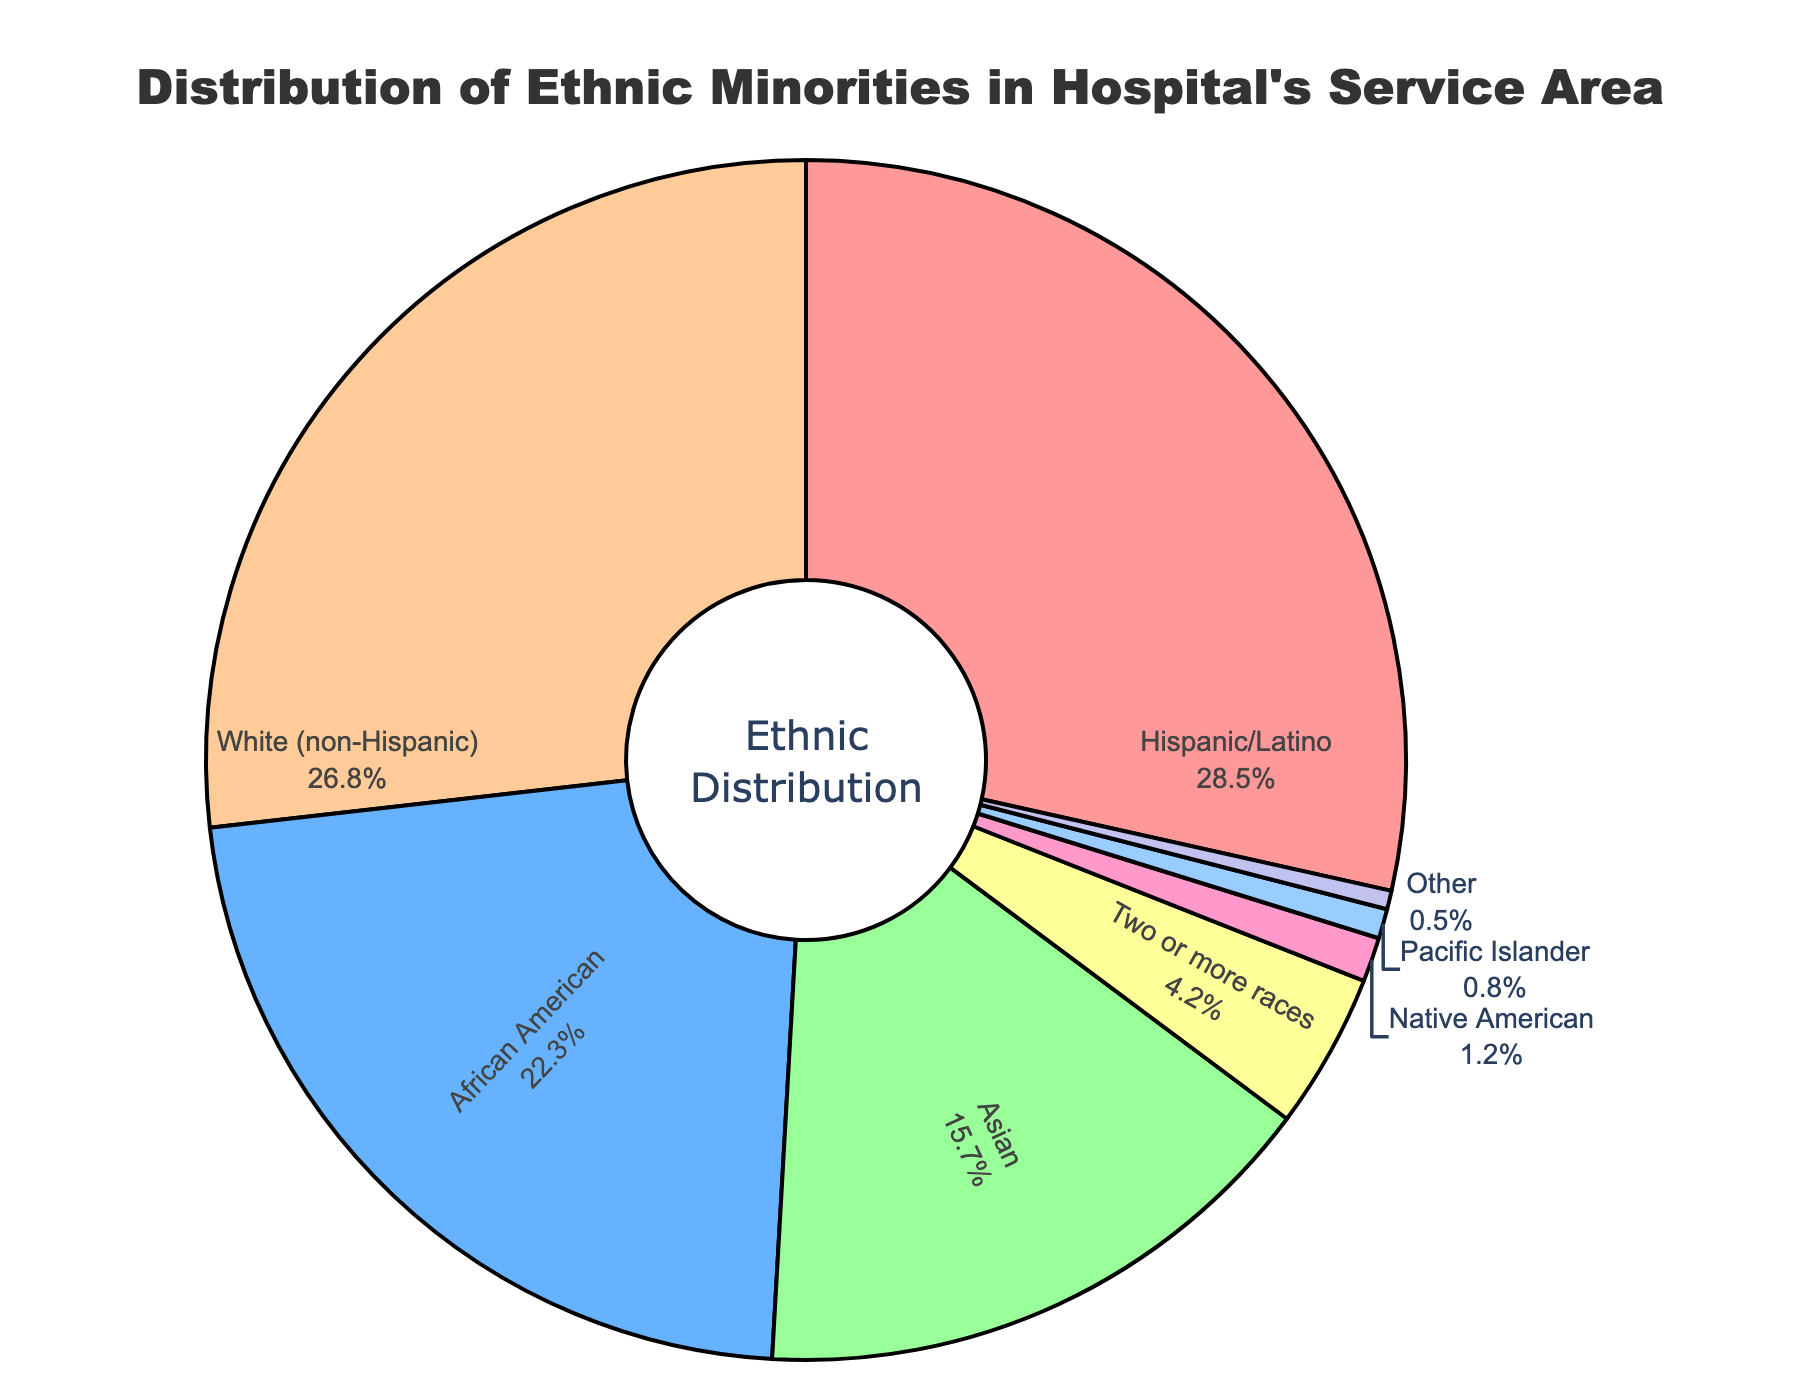What percentage of the hospital's service area is made up of Hispanic/Latino individuals? From the figure, we can see the percentage labeled next to the "Hispanic/Latino" section.
Answer: 28.5% Which ethnic group has the smallest representation in the hospital's service area? To answer this, we need to identify the smallest percentage on the figure. The smallest labeled section is "Other" with 0.5%.
Answer: Other Is the proportion of African American individuals higher than that of Asian individuals? Compare the percentages labeled for "African American" and "Asian". African American is 22.3% and Asian is 15.7%, so yes, African American is higher.
Answer: Yes What is the combined percentage of Native American and Pacific Islander groups? Sum the percentages of Native American (1.2%) and Pacific Islander (0.8%). 1.2 + 0.8 = 2.0%.
Answer: 2.0% How does the percentage of White (non-Hispanic) individuals compare to the total percentage of Two or more races and Other ethnic groups? The percentage for White (non-Hispanic) is 26.8%. The combined percentage of Two or more races (4.2%) and Other (0.5%) is 4.7%. Since 26.8% > 4.7%, White (non-Hispanic) is higher.
Answer: Higher Which ethnic group has a representation close to 1% but not exceeding it? From the figure, identify the group with a percentage near to but not more than 1%. Native American is 1.2%, so it exceeds 1%. Pacific Islander is 0.8%, which is close and under 1%.
Answer: Pacific Islander What is the difference in the percentage of Hispanic/Latino and White (non-Hispanic) individuals? Subtract the percentage of White (non-Hispanic) from Hispanic/Latino. 28.5% - 26.8% = 1.7%.
Answer: 1.7% Can you identify which group has the highest percentage in the figure? Look at the percentages and determine the highest. Hispanic/Latino has the highest at 28.5%.
Answer: Hispanic/Latino What is the average percentage of all ethnic groups represented in the hospital's service area? Sum all the percentages and divide by the number of groups: (28.5 + 22.3 + 15.7 + 26.8 + 1.2 + 0.8 + 4.2 + 0.5) / 8 = 12.5%.
Answer: 12.5% Among the groups, which have percentages higher than the average percentage? Calculate the average percentage as 12.5% and identify groups with percentages higher than this value. Hispanic/Latino (28.5%), African American (22.3%), Asian (15.7%), and White (non-Hispanic) (26.8%) are above 12.5%.
Answer: Hispanic/Latino, African American, Asian, White (non-Hispanic) 